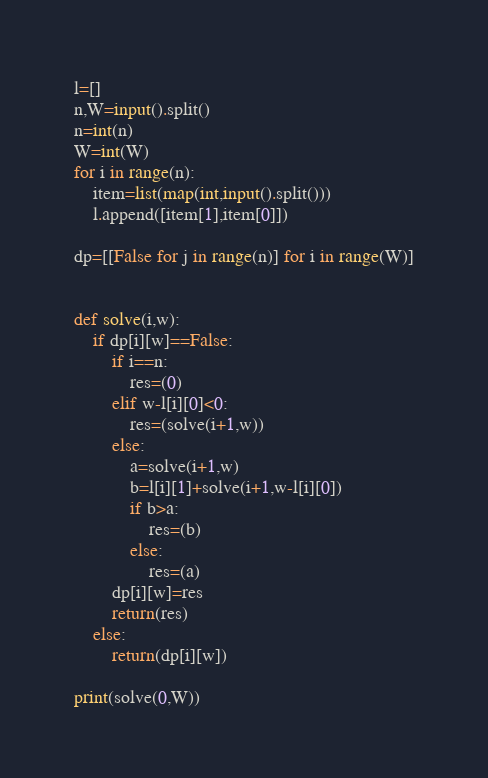Convert code to text. <code><loc_0><loc_0><loc_500><loc_500><_Python_>l=[]
n,W=input().split()
n=int(n)
W=int(W)
for i in range(n):
	item=list(map(int,input().split()))
	l.append([item[1],item[0]])

dp=[[False for j in range(n)] for i in range(W)]


def solve(i,w):
	if dp[i][w]==False:
		if i==n:
			res=(0)
		elif w-l[i][0]<0:
			res=(solve(i+1,w))
		else:
			a=solve(i+1,w)
			b=l[i][1]+solve(i+1,w-l[i][0])
			if b>a:
				res=(b)
			else:
				res=(a)
		dp[i][w]=res
		return(res)
	else:
		return(dp[i][w])

print(solve(0,W))</code> 